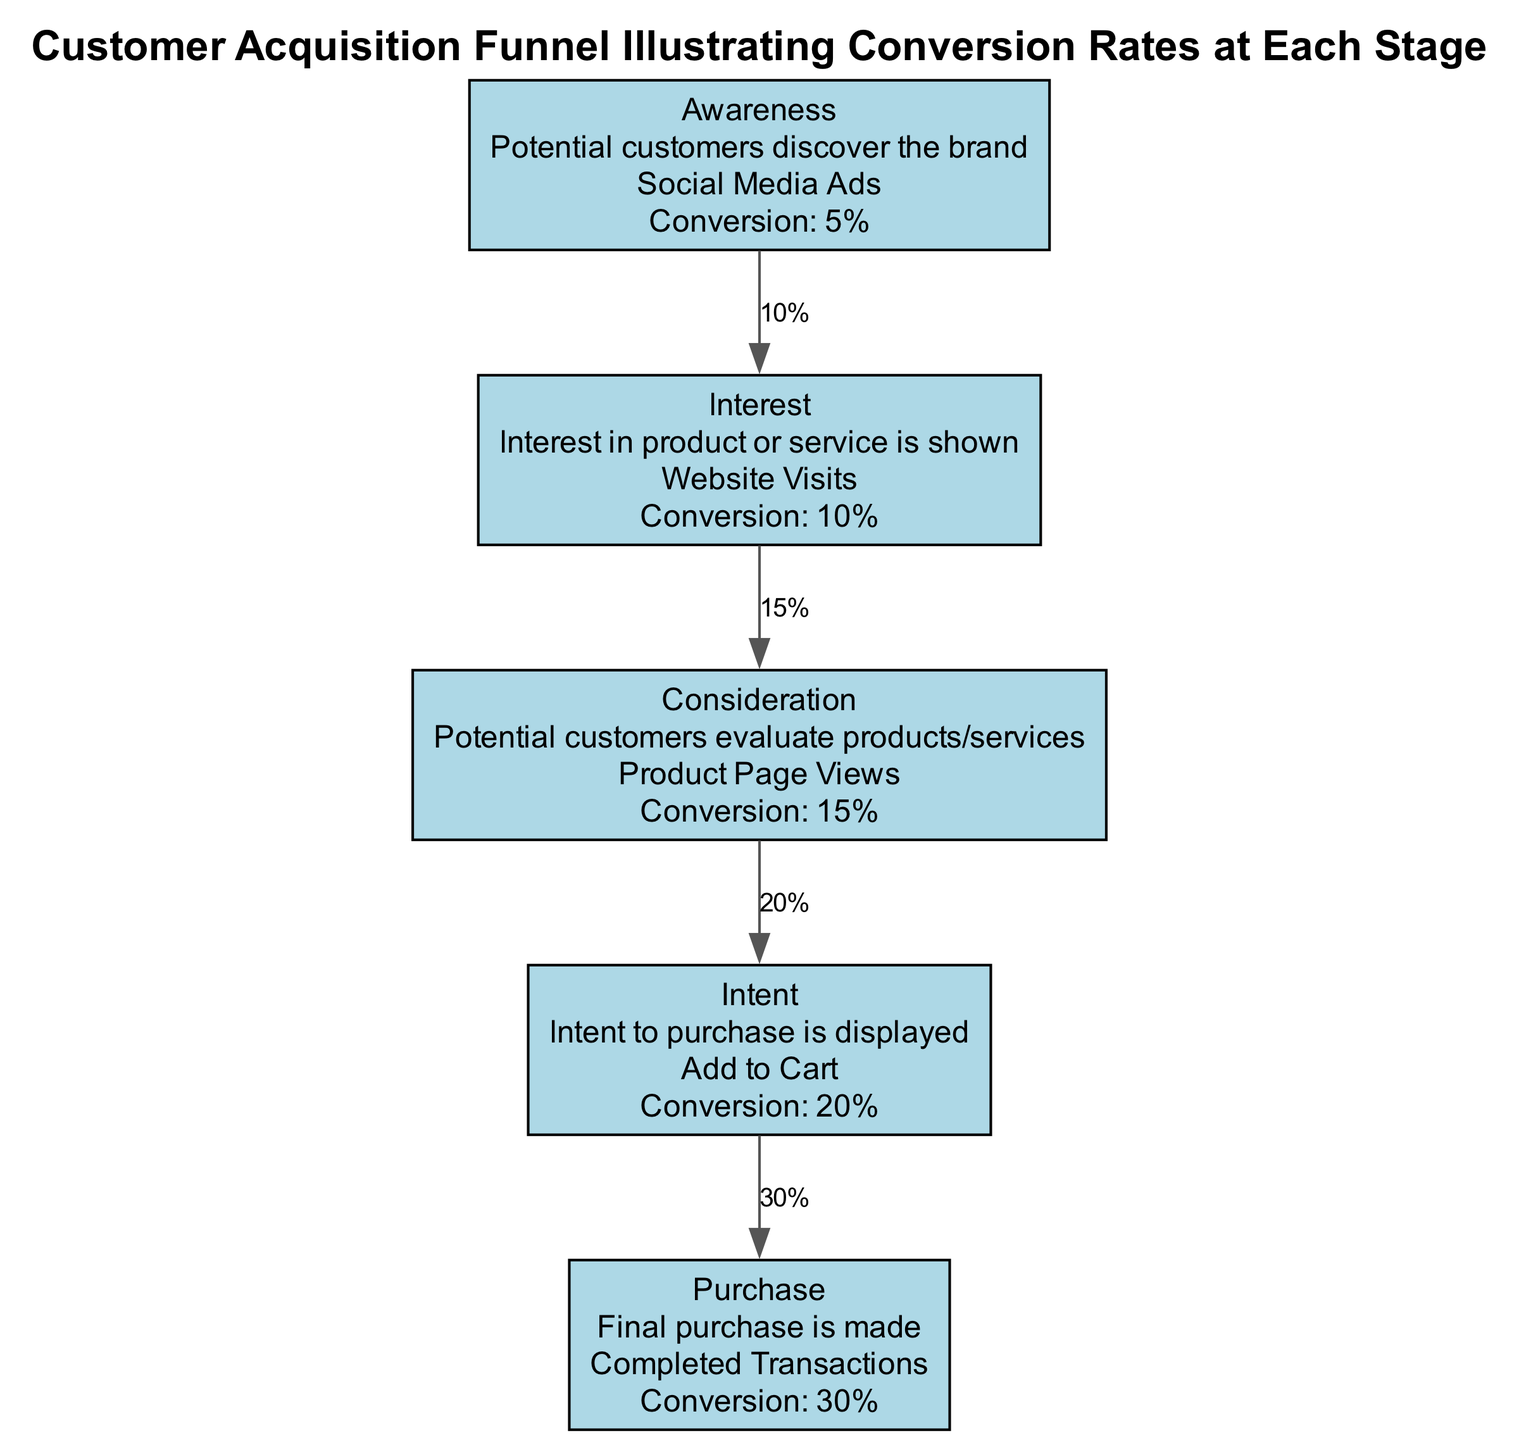What is the conversion rate at the Interest stage? According to the diagram, the Interest stage shows a conversion rate of 10%.
Answer: 10% How many stages are there in the customer acquisition funnel? The diagram lists five stages: Awareness, Interest, Consideration, Intent, and Purchase. Thus, there are five stages in total.
Answer: 5 Which stage has the highest conversion rate? The Purchase stage has the highest conversion rate at 30%, as indicated in the diagram.
Answer: 30% What examples are provided for the Consideration stage? The diagram states that the example for the Consideration stage is "Product Page Views."
Answer: Product Page Views What conversion rate is displayed between the Intent and Purchase stages? The conversion rate from Intent to Purchase is 30%, as shown by the arrow connecting these two stages.
Answer: 30% If the conversion rate in the Awareness stage increases to 10%, how would this impact the Interest stage? The Interest stage's conversion rate is separate and remains at 10%, regardless of the Awareness stage's initial conversion rate.
Answer: Remains at 10% What flow does the arrow from Awareness to Interest represent? The arrow from Awareness to Interest denotes the conversion rate of 10%, indicating how many of the aware customers show interest.
Answer: 10% What is the common theme for all examples in the funnel? All examples reflect digital touchpoints with potential customers throughout their journey in acquiring the product or service.
Answer: Digital touchpoints What stage follows the Consideration stage? The stage that follows Consideration, according to the diagram, is the Intent stage.
Answer: Intent 